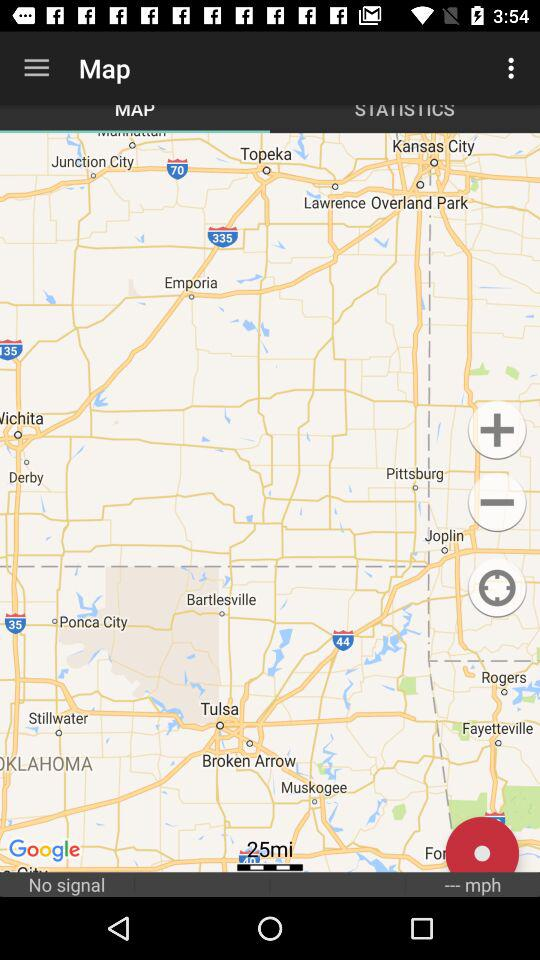Which tab is selected? The selected tab is "MAP". 